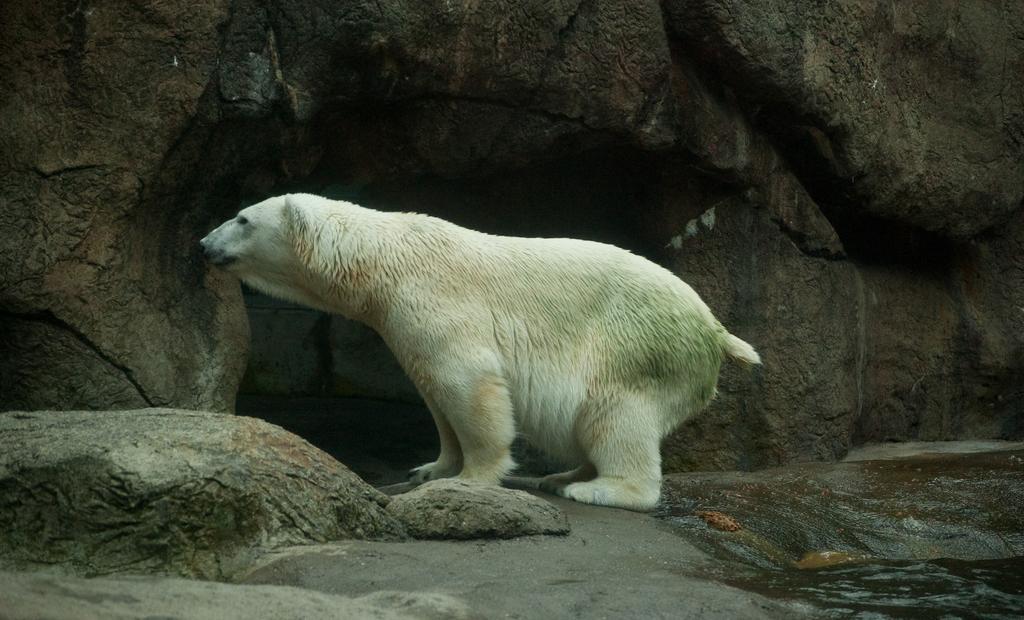Can you describe this image briefly? In this image we can see a white polar bear, there is the water, there are rocks, there is a den. 